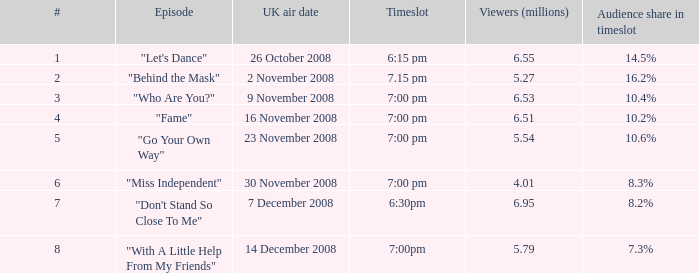Can you parse all the data within this table? {'header': ['#', 'Episode', 'UK air date', 'Timeslot', 'Viewers (millions)', 'Audience share in timeslot'], 'rows': [['1', '"Let\'s Dance"', '26 October 2008', '6:15 pm', '6.55', '14.5%'], ['2', '"Behind the Mask"', '2 November 2008', '7.15 pm', '5.27', '16.2%'], ['3', '"Who Are You?"', '9 November 2008', '7:00 pm', '6.53', '10.4%'], ['4', '"Fame"', '16 November 2008', '7:00 pm', '6.51', '10.2%'], ['5', '"Go Your Own Way"', '23 November 2008', '7:00 pm', '5.54', '10.6%'], ['6', '"Miss Independent"', '30 November 2008', '7:00 pm', '4.01', '8.3%'], ['7', '"Don\'t Stand So Close To Me"', '7 December 2008', '6:30pm', '6.95', '8.2%'], ['8', '"With A Little Help From My Friends"', '14 December 2008', '7:00pm', '5.79', '7.3%']]} Name the uk air date for audience share in timeslot in 7.3% 14 December 2008. 